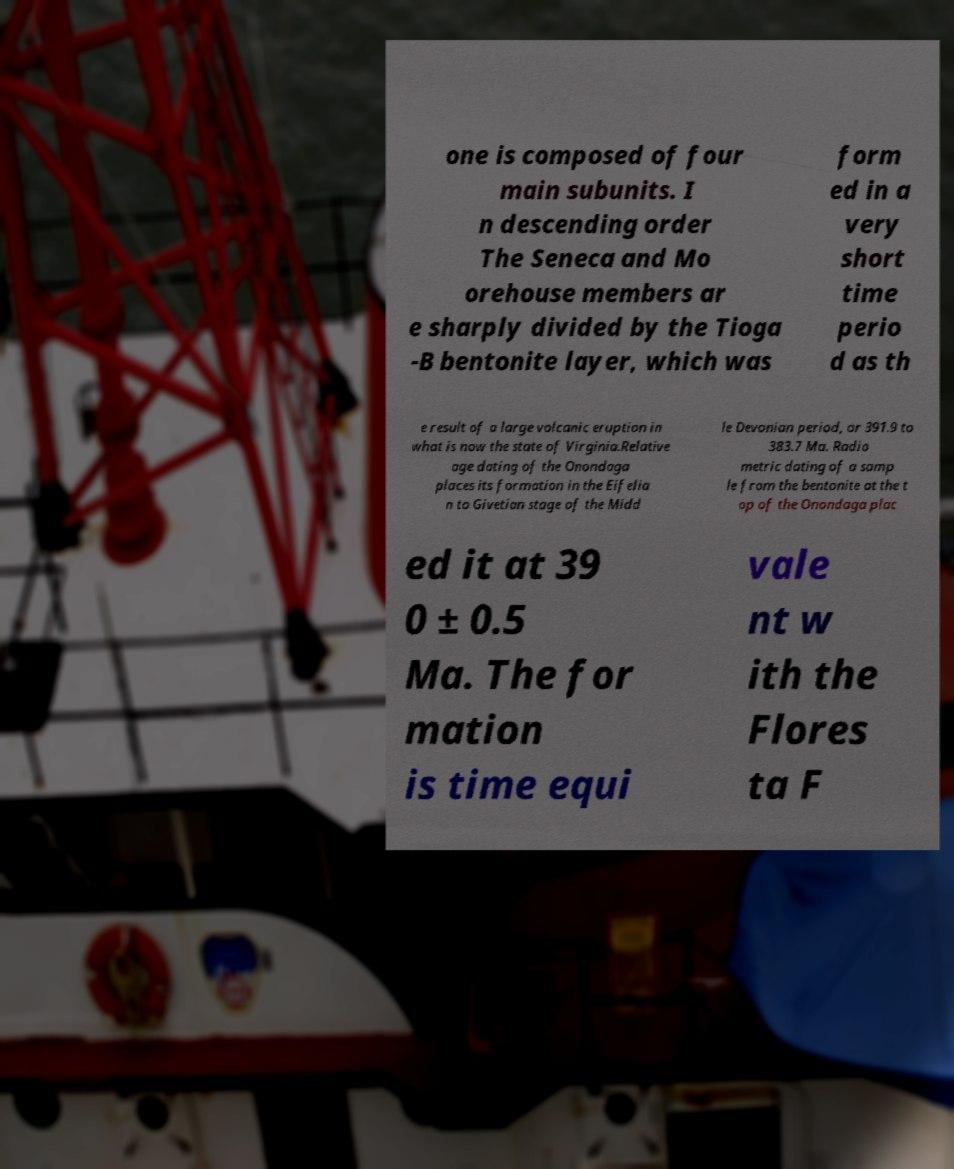For documentation purposes, I need the text within this image transcribed. Could you provide that? one is composed of four main subunits. I n descending order The Seneca and Mo orehouse members ar e sharply divided by the Tioga -B bentonite layer, which was form ed in a very short time perio d as th e result of a large volcanic eruption in what is now the state of Virginia.Relative age dating of the Onondaga places its formation in the Eifelia n to Givetian stage of the Midd le Devonian period, or 391.9 to 383.7 Ma. Radio metric dating of a samp le from the bentonite at the t op of the Onondaga plac ed it at 39 0 ± 0.5 Ma. The for mation is time equi vale nt w ith the Flores ta F 